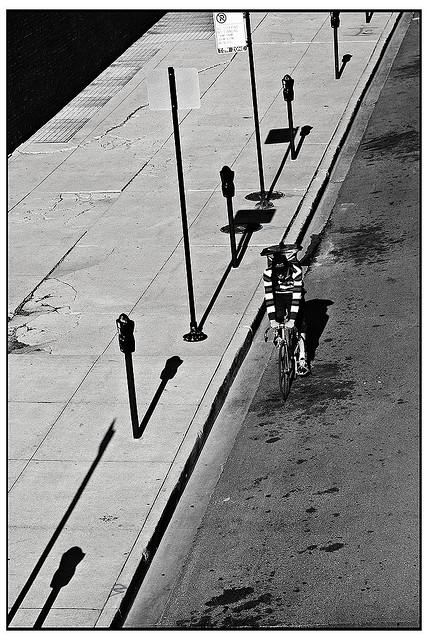What kind of vehicle is the person driving up next to the street?

Choices:
A) bike
B) pickup
C) streetsweeper
D) van bike 